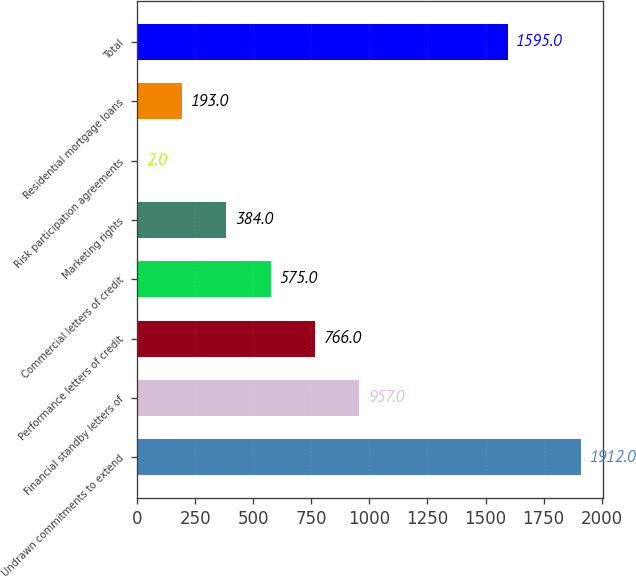<chart> <loc_0><loc_0><loc_500><loc_500><bar_chart><fcel>Undrawn commitments to extend<fcel>Financial standby letters of<fcel>Performance letters of credit<fcel>Commercial letters of credit<fcel>Marketing rights<fcel>Risk participation agreements<fcel>Residential mortgage loans<fcel>Total<nl><fcel>1912<fcel>957<fcel>766<fcel>575<fcel>384<fcel>2<fcel>193<fcel>1595<nl></chart> 